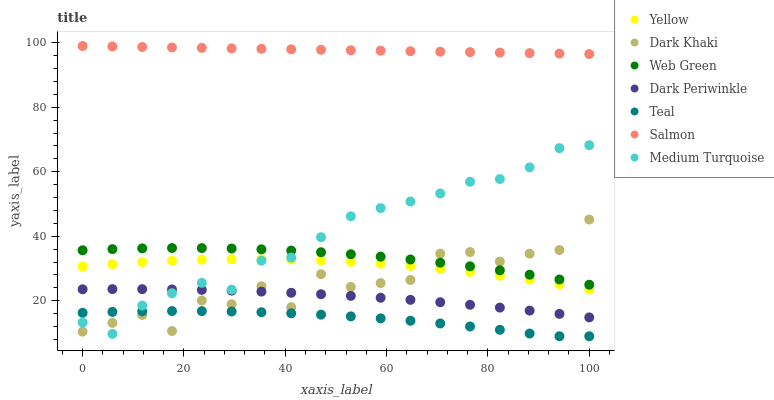Does Teal have the minimum area under the curve?
Answer yes or no. Yes. Does Salmon have the maximum area under the curve?
Answer yes or no. Yes. Does Web Green have the minimum area under the curve?
Answer yes or no. No. Does Web Green have the maximum area under the curve?
Answer yes or no. No. Is Salmon the smoothest?
Answer yes or no. Yes. Is Dark Khaki the roughest?
Answer yes or no. Yes. Is Web Green the smoothest?
Answer yes or no. No. Is Web Green the roughest?
Answer yes or no. No. Does Teal have the lowest value?
Answer yes or no. Yes. Does Web Green have the lowest value?
Answer yes or no. No. Does Salmon have the highest value?
Answer yes or no. Yes. Does Web Green have the highest value?
Answer yes or no. No. Is Teal less than Dark Periwinkle?
Answer yes or no. Yes. Is Salmon greater than Dark Khaki?
Answer yes or no. Yes. Does Yellow intersect Medium Turquoise?
Answer yes or no. Yes. Is Yellow less than Medium Turquoise?
Answer yes or no. No. Is Yellow greater than Medium Turquoise?
Answer yes or no. No. Does Teal intersect Dark Periwinkle?
Answer yes or no. No. 